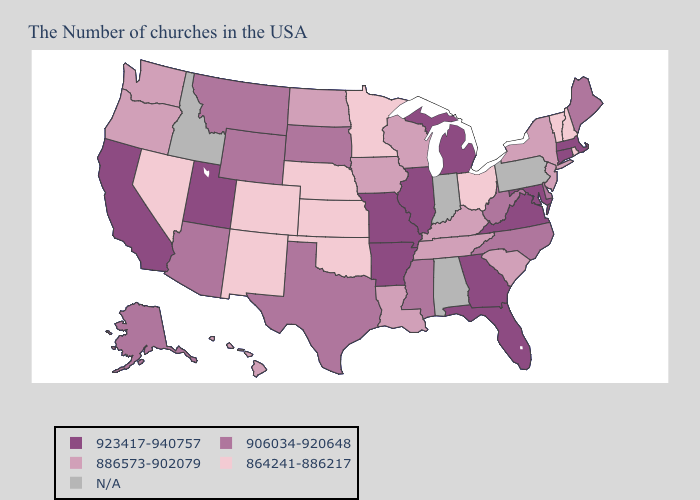Name the states that have a value in the range 923417-940757?
Write a very short answer. Massachusetts, Connecticut, Maryland, Virginia, Florida, Georgia, Michigan, Illinois, Missouri, Arkansas, Utah, California. What is the highest value in the Northeast ?
Be succinct. 923417-940757. Does the first symbol in the legend represent the smallest category?
Keep it brief. No. Which states have the highest value in the USA?
Give a very brief answer. Massachusetts, Connecticut, Maryland, Virginia, Florida, Georgia, Michigan, Illinois, Missouri, Arkansas, Utah, California. What is the highest value in states that border Nevada?
Answer briefly. 923417-940757. What is the lowest value in the South?
Give a very brief answer. 864241-886217. What is the value of South Carolina?
Be succinct. 886573-902079. What is the value of North Carolina?
Quick response, please. 906034-920648. What is the value of South Dakota?
Write a very short answer. 906034-920648. Which states hav the highest value in the West?
Write a very short answer. Utah, California. Name the states that have a value in the range 864241-886217?
Quick response, please. Rhode Island, New Hampshire, Vermont, Ohio, Minnesota, Kansas, Nebraska, Oklahoma, Colorado, New Mexico, Nevada. Which states hav the highest value in the Northeast?
Quick response, please. Massachusetts, Connecticut. What is the value of Virginia?
Be succinct. 923417-940757. 